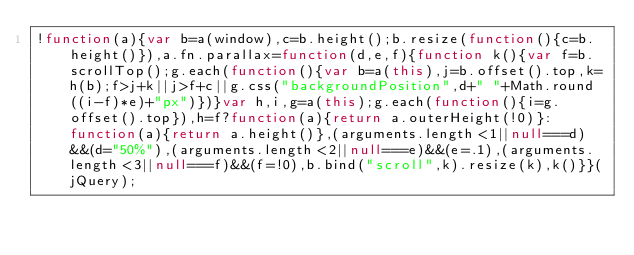<code> <loc_0><loc_0><loc_500><loc_500><_JavaScript_>!function(a){var b=a(window),c=b.height();b.resize(function(){c=b.height()}),a.fn.parallax=function(d,e,f){function k(){var f=b.scrollTop();g.each(function(){var b=a(this),j=b.offset().top,k=h(b);f>j+k||j>f+c||g.css("backgroundPosition",d+" "+Math.round((i-f)*e)+"px")})}var h,i,g=a(this);g.each(function(){i=g.offset().top}),h=f?function(a){return a.outerHeight(!0)}:function(a){return a.height()},(arguments.length<1||null===d)&&(d="50%"),(arguments.length<2||null===e)&&(e=.1),(arguments.length<3||null===f)&&(f=!0),b.bind("scroll",k).resize(k),k()}}(jQuery);
</code> 